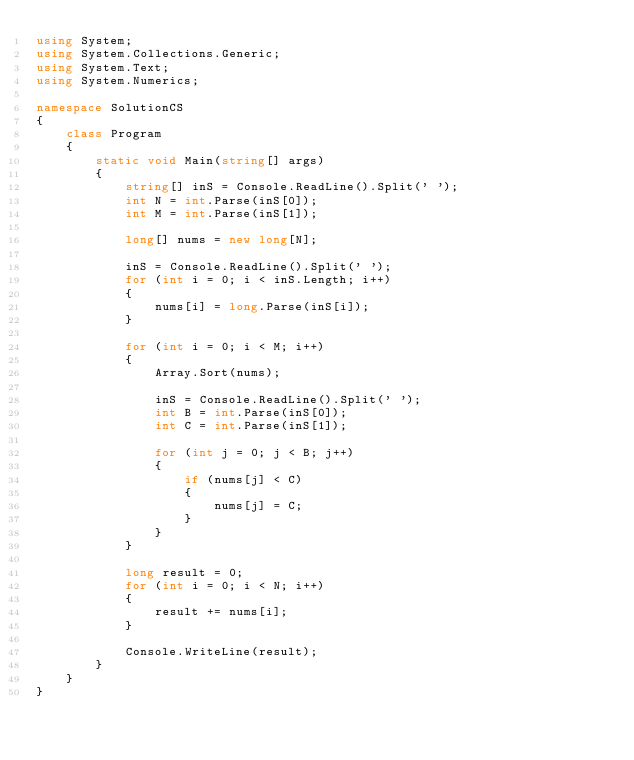Convert code to text. <code><loc_0><loc_0><loc_500><loc_500><_C#_>using System;
using System.Collections.Generic;
using System.Text;
using System.Numerics;

namespace SolutionCS
{
    class Program
    {
        static void Main(string[] args)
        {
            string[] inS = Console.ReadLine().Split(' ');
            int N = int.Parse(inS[0]);
            int M = int.Parse(inS[1]);

            long[] nums = new long[N];

            inS = Console.ReadLine().Split(' ');
            for (int i = 0; i < inS.Length; i++)
            {
                nums[i] = long.Parse(inS[i]);
            }

            for (int i = 0; i < M; i++)
            {
                Array.Sort(nums);

                inS = Console.ReadLine().Split(' ');
                int B = int.Parse(inS[0]);
                int C = int.Parse(inS[1]);

                for (int j = 0; j < B; j++)
                {
                    if (nums[j] < C)
                    {
                        nums[j] = C;
                    }
                }
            }

            long result = 0;
            for (int i = 0; i < N; i++)
            {
                result += nums[i];
            }

            Console.WriteLine(result);
        }
    }
}
</code> 